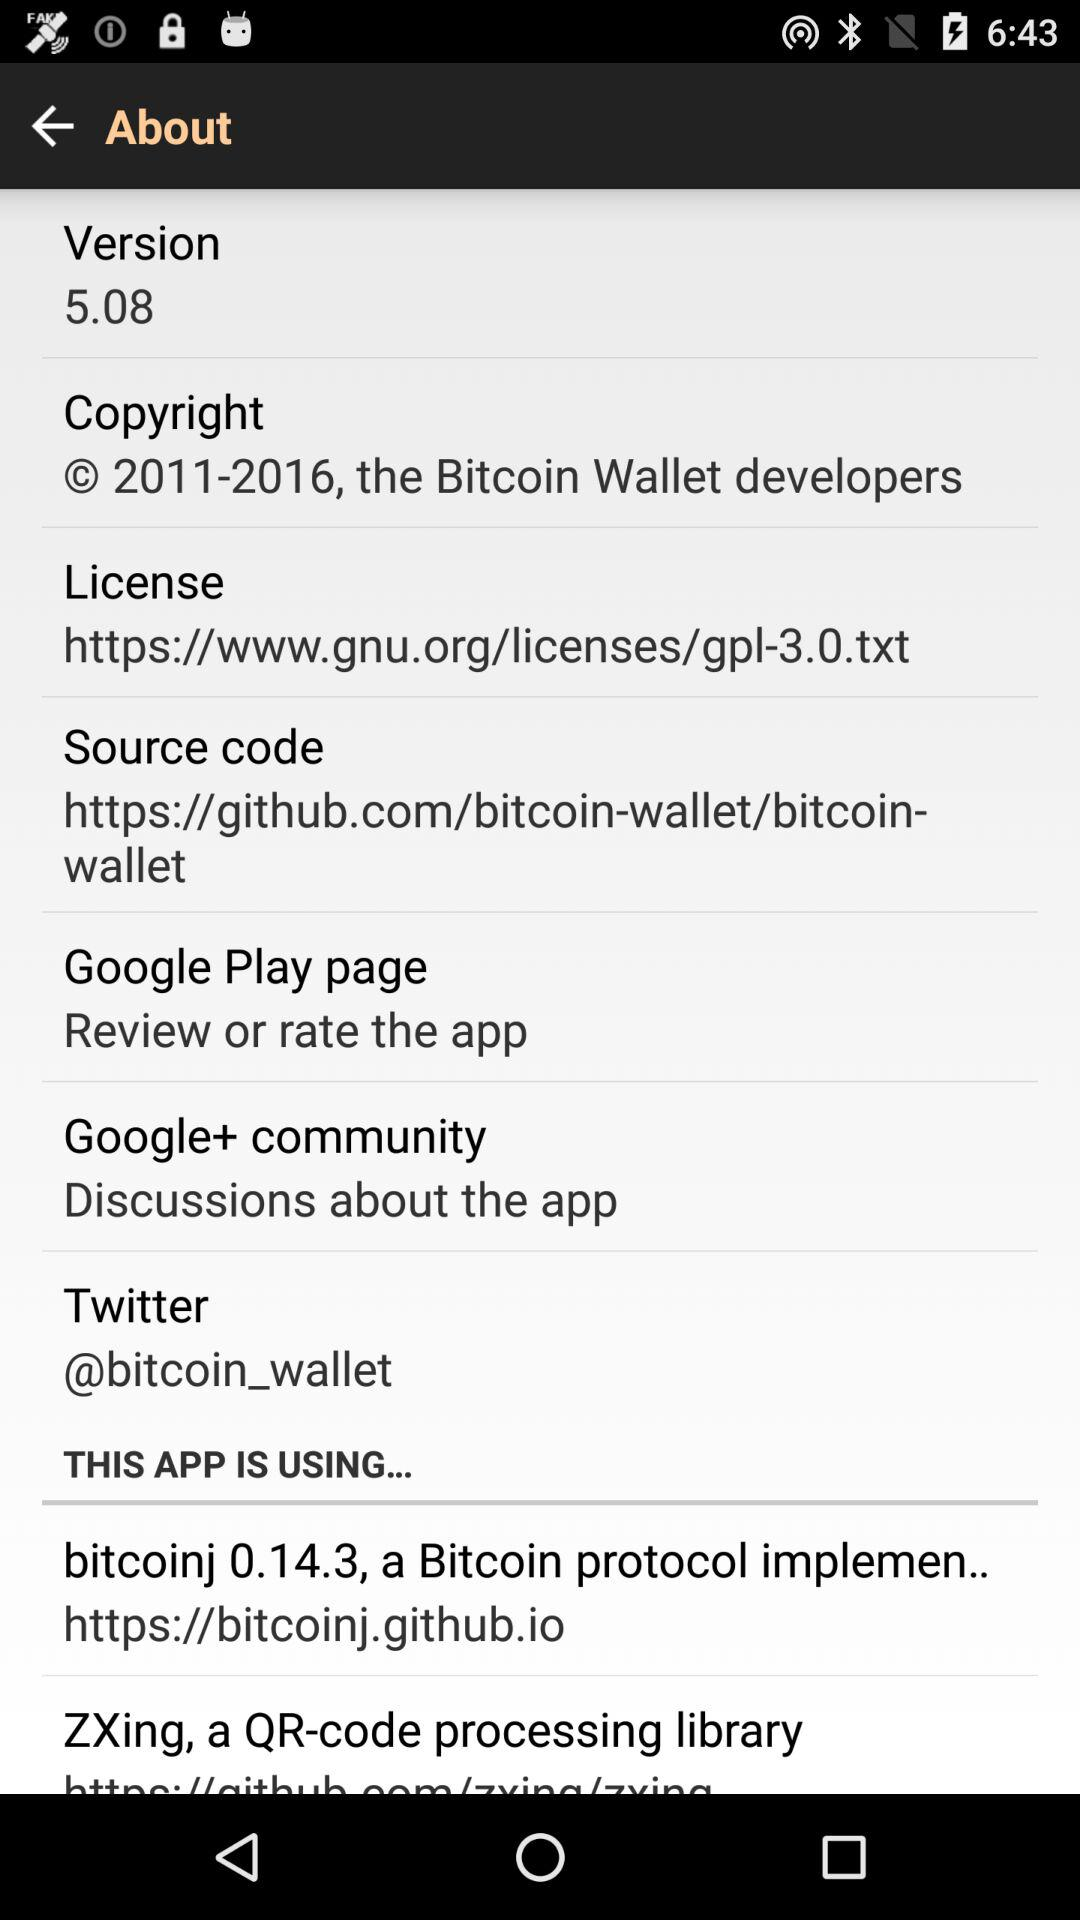What version is used? The used version is 5.08. 